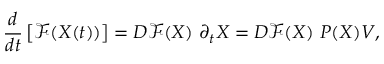<formula> <loc_0><loc_0><loc_500><loc_500>\frac { d } { d t } \left [ \mathcal { F } ( X ( t ) ) \right ] = D \mathcal { F } ( X ) \partial _ { t } { X } = D \mathcal { F } ( X ) P ( X ) V ,</formula> 